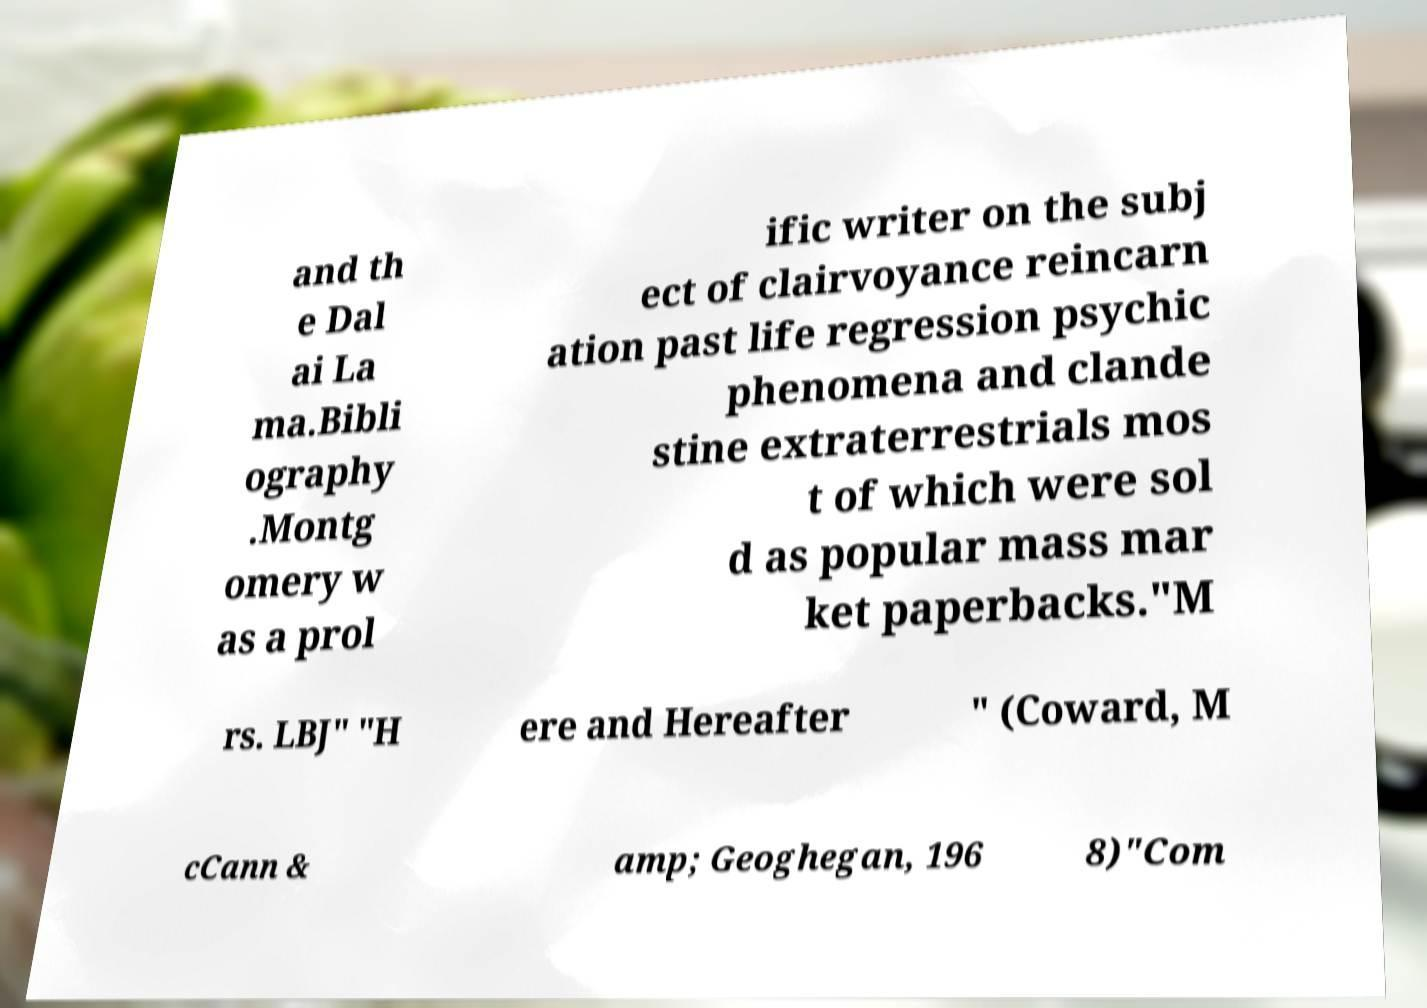I need the written content from this picture converted into text. Can you do that? and th e Dal ai La ma.Bibli ography .Montg omery w as a prol ific writer on the subj ect of clairvoyance reincarn ation past life regression psychic phenomena and clande stine extraterrestrials mos t of which were sol d as popular mass mar ket paperbacks."M rs. LBJ" "H ere and Hereafter " (Coward, M cCann & amp; Geoghegan, 196 8)"Com 